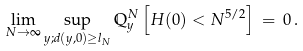Convert formula to latex. <formula><loc_0><loc_0><loc_500><loc_500>\lim _ { N \rightarrow \infty } \sup _ { y ; d ( y , 0 ) \geq l _ { N } } \mathbb { Q } ^ { N } _ { y } \left [ H ( 0 ) < N ^ { 5 / 2 } \right ] \, = \, 0 \, .</formula> 